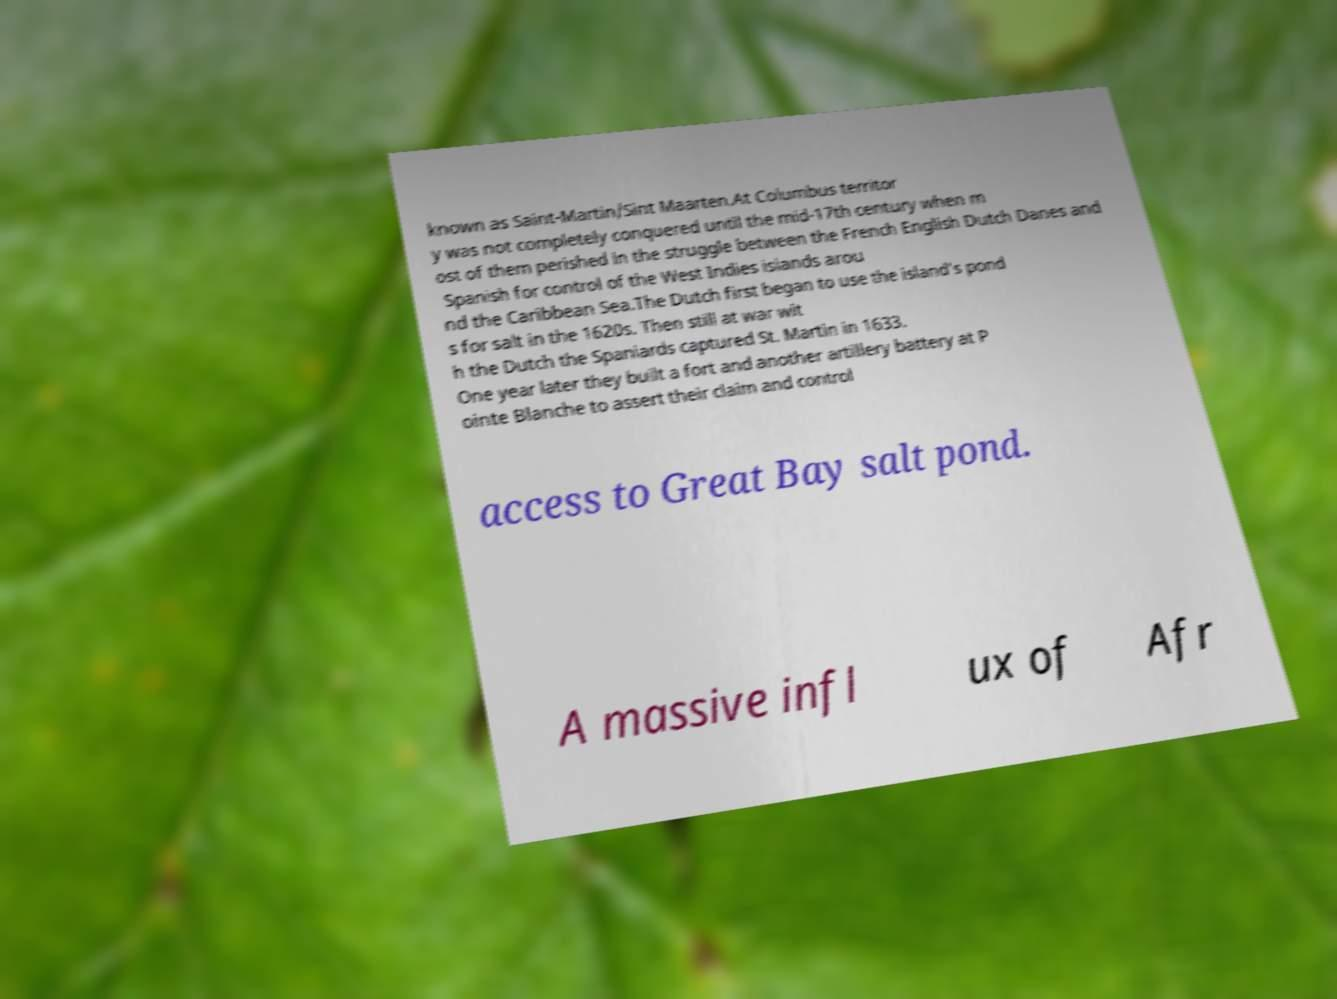Please read and relay the text visible in this image. What does it say? known as Saint-Martin/Sint Maarten.At Columbus territor y was not completely conquered until the mid-17th century when m ost of them perished in the struggle between the French English Dutch Danes and Spanish for control of the West Indies islands arou nd the Caribbean Sea.The Dutch first began to use the island's pond s for salt in the 1620s. Then still at war wit h the Dutch the Spaniards captured St. Martin in 1633. One year later they built a fort and another artillery battery at P ointe Blanche to assert their claim and control access to Great Bay salt pond. A massive infl ux of Afr 